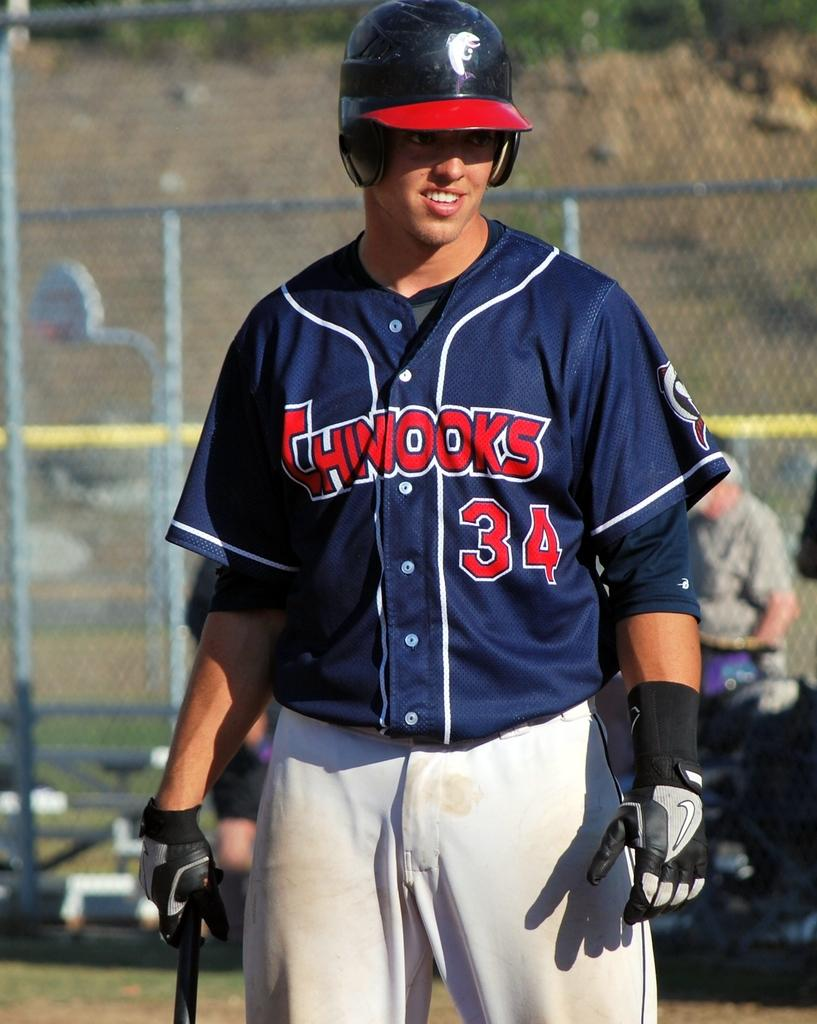<image>
Render a clear and concise summary of the photo. A Chinooks player wears a batting helmet and the number 34 on his uniform. 